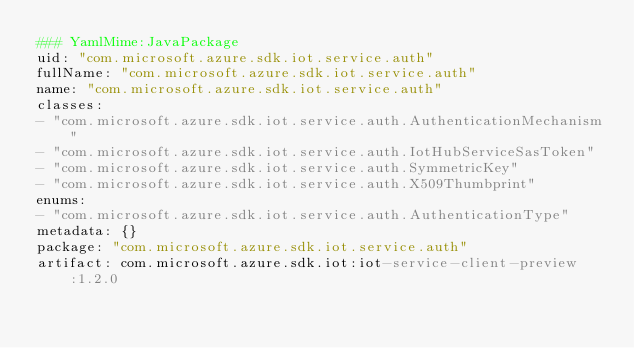<code> <loc_0><loc_0><loc_500><loc_500><_YAML_>### YamlMime:JavaPackage
uid: "com.microsoft.azure.sdk.iot.service.auth"
fullName: "com.microsoft.azure.sdk.iot.service.auth"
name: "com.microsoft.azure.sdk.iot.service.auth"
classes:
- "com.microsoft.azure.sdk.iot.service.auth.AuthenticationMechanism"
- "com.microsoft.azure.sdk.iot.service.auth.IotHubServiceSasToken"
- "com.microsoft.azure.sdk.iot.service.auth.SymmetricKey"
- "com.microsoft.azure.sdk.iot.service.auth.X509Thumbprint"
enums:
- "com.microsoft.azure.sdk.iot.service.auth.AuthenticationType"
metadata: {}
package: "com.microsoft.azure.sdk.iot.service.auth"
artifact: com.microsoft.azure.sdk.iot:iot-service-client-preview:1.2.0
</code> 